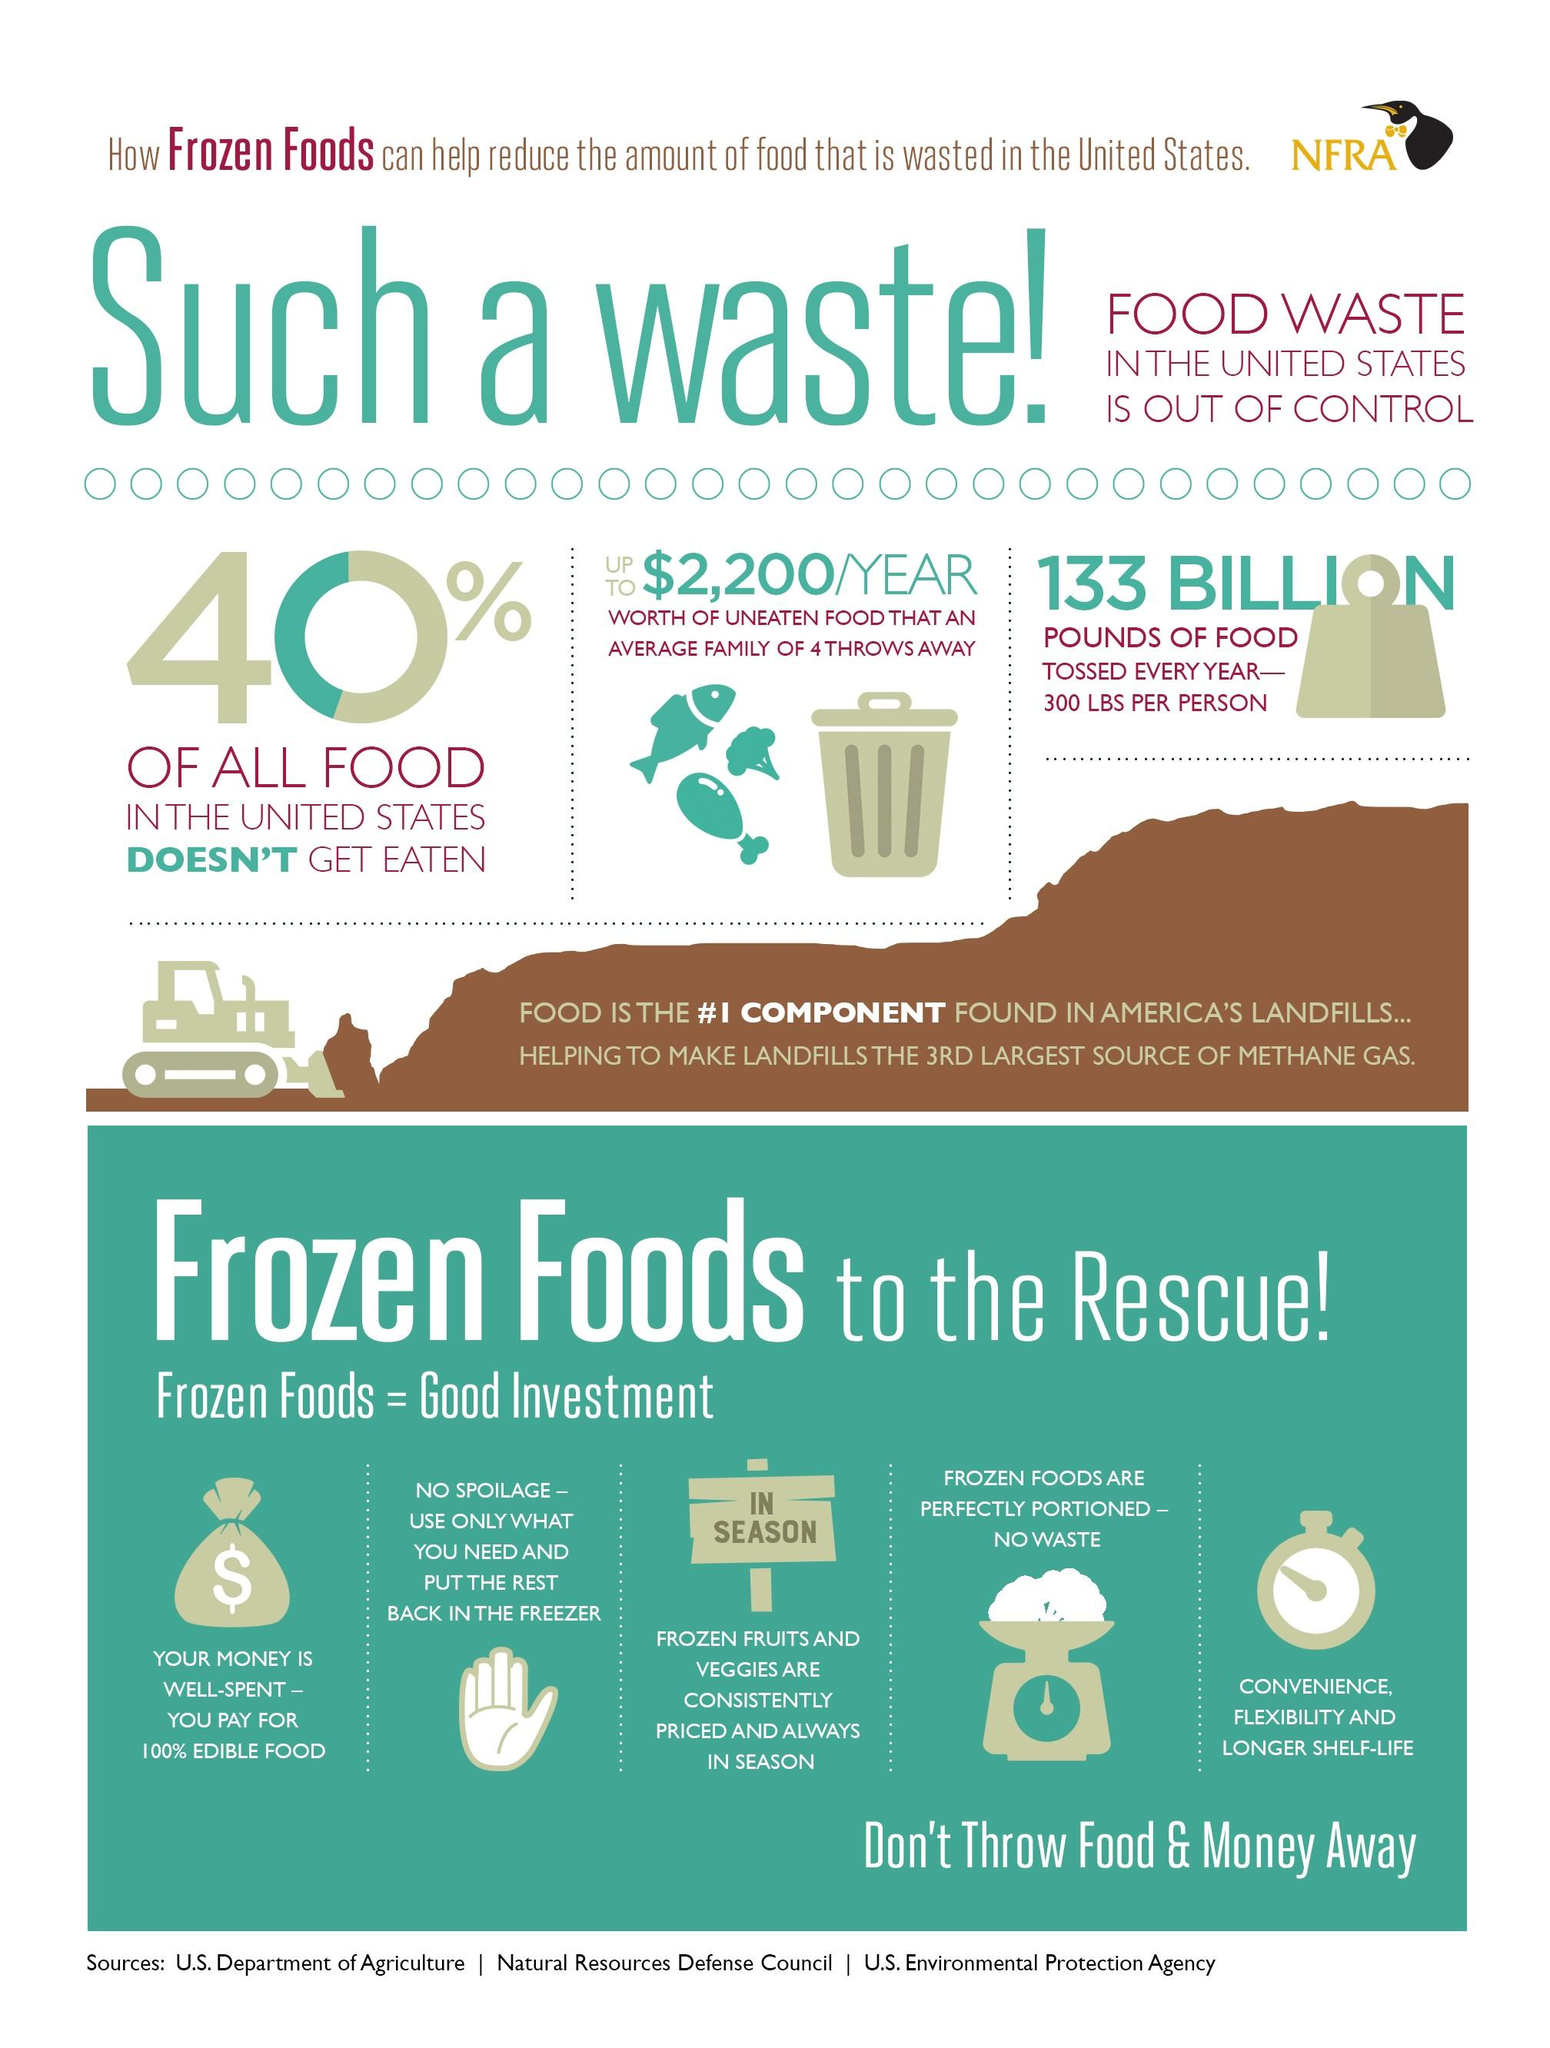Mention a couple of crucial points in this snapshot. The total weight of food wasted in the US each year is 133 billion pounds. On average, a family of four in the United States wastes approximately $2,200 worth of food each year, according to recent estimates. Frozen foods are known for having a longer shelf life than their fresh counterparts. Frozen foods are perfectly portioned, ensuring that no waste is produced, which is the fourth reason for choosing them. The image on the placard displays text that reads, 'In season...' 